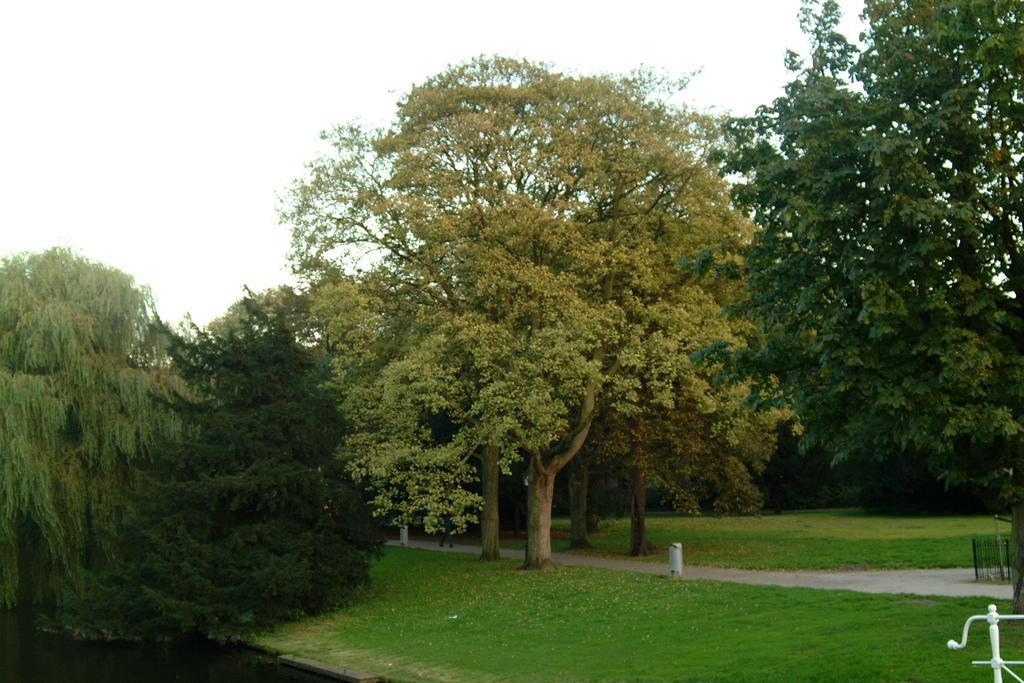Could you give a brief overview of what you see in this image? In this image we can see a group of trees, some grass, a pathway, a fence, the metal poles and the sky which looks cloudy. 